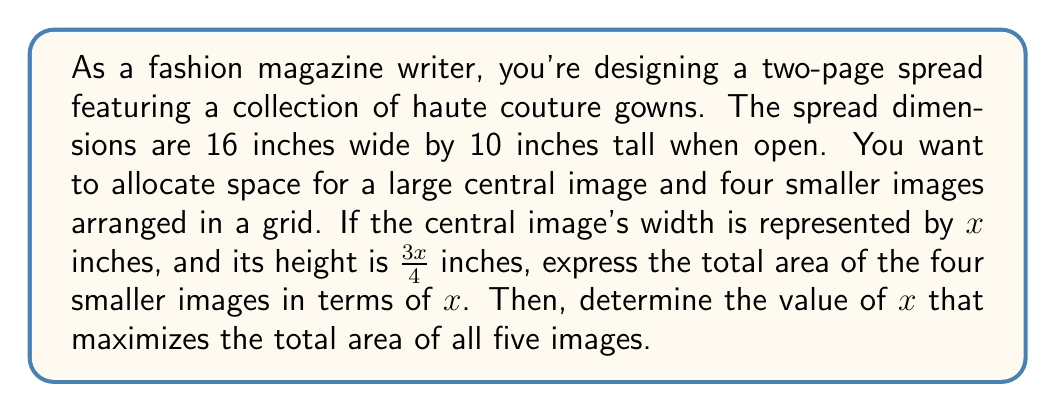Could you help me with this problem? Let's approach this step-by-step:

1) The total area of the spread is 16 × 10 = 160 square inches.

2) The area of the central image is $x \cdot \frac{3x}{4} = \frac{3x^2}{4}$ square inches.

3) The remaining area for the four smaller images is:
   $160 - \frac{3x^2}{4}$ square inches

4) To maximize the total area of all five images, we need to maximize:
   $f(x) = \frac{3x^2}{4} + (160 - \frac{3x^2}{4}) = 160$

5) This shows that the total area is constant regardless of $x$. However, we need to consider the constraints:
   - The central image can't be wider than the spread: $x \leq 16$
   - The central image can't be taller than the spread: $\frac{3x}{4} \leq 10$

6) From the height constraint: $\frac{3x}{4} \leq 10$, we get $x \leq \frac{40}{3}$

7) The binding constraint is $x \leq \frac{40}{3}$ (approximately 13.33 inches), as it's smaller than 16.

8) To maximize the area of the central image (and consequently, the area of the smaller images), we should use the maximum allowed value for $x$: $\frac{40}{3}$

9) The area of the central image is then:
   $\frac{3}{4} \cdot (\frac{40}{3})^2 = 400/3$ square inches

10) The total area of the four smaller images is:
    $160 - 400/3 = 80/3$ square inches
Answer: $x = \frac{40}{3}$ inches; Central image area: $\frac{400}{3}$ sq in; Total smaller images area: $\frac{80}{3}$ sq in 